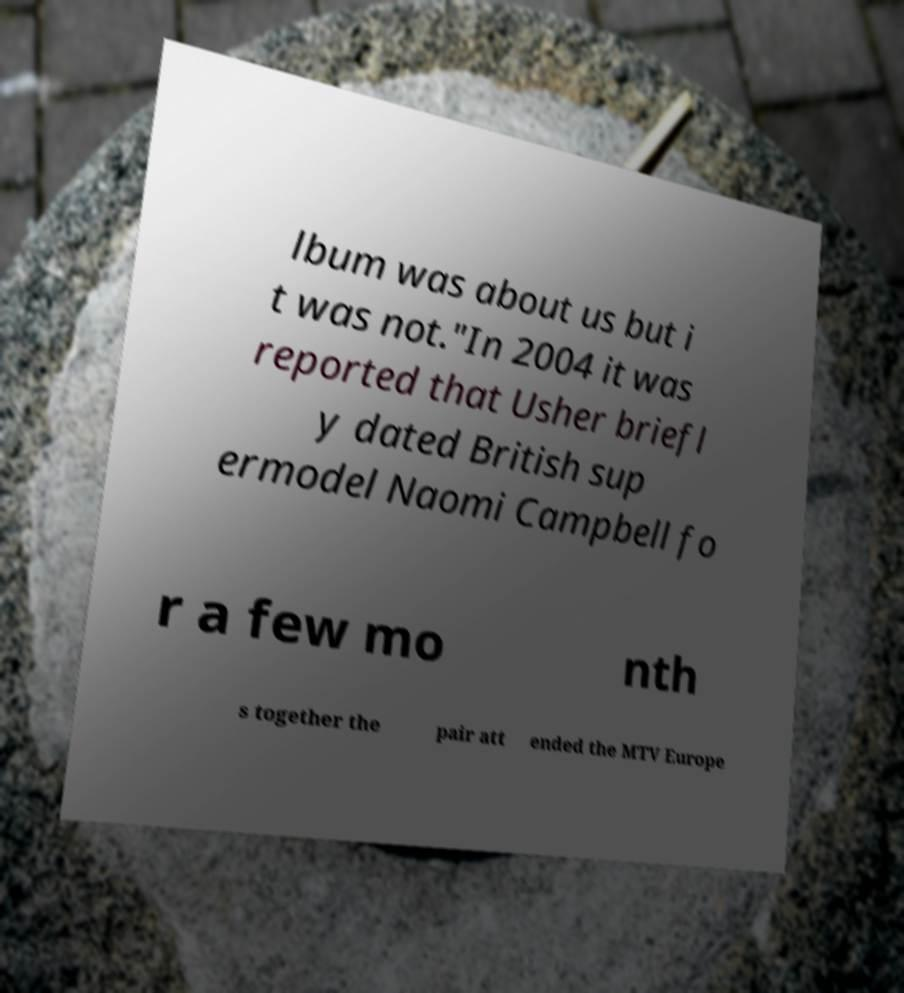Can you accurately transcribe the text from the provided image for me? lbum was about us but i t was not."In 2004 it was reported that Usher briefl y dated British sup ermodel Naomi Campbell fo r a few mo nth s together the pair att ended the MTV Europe 